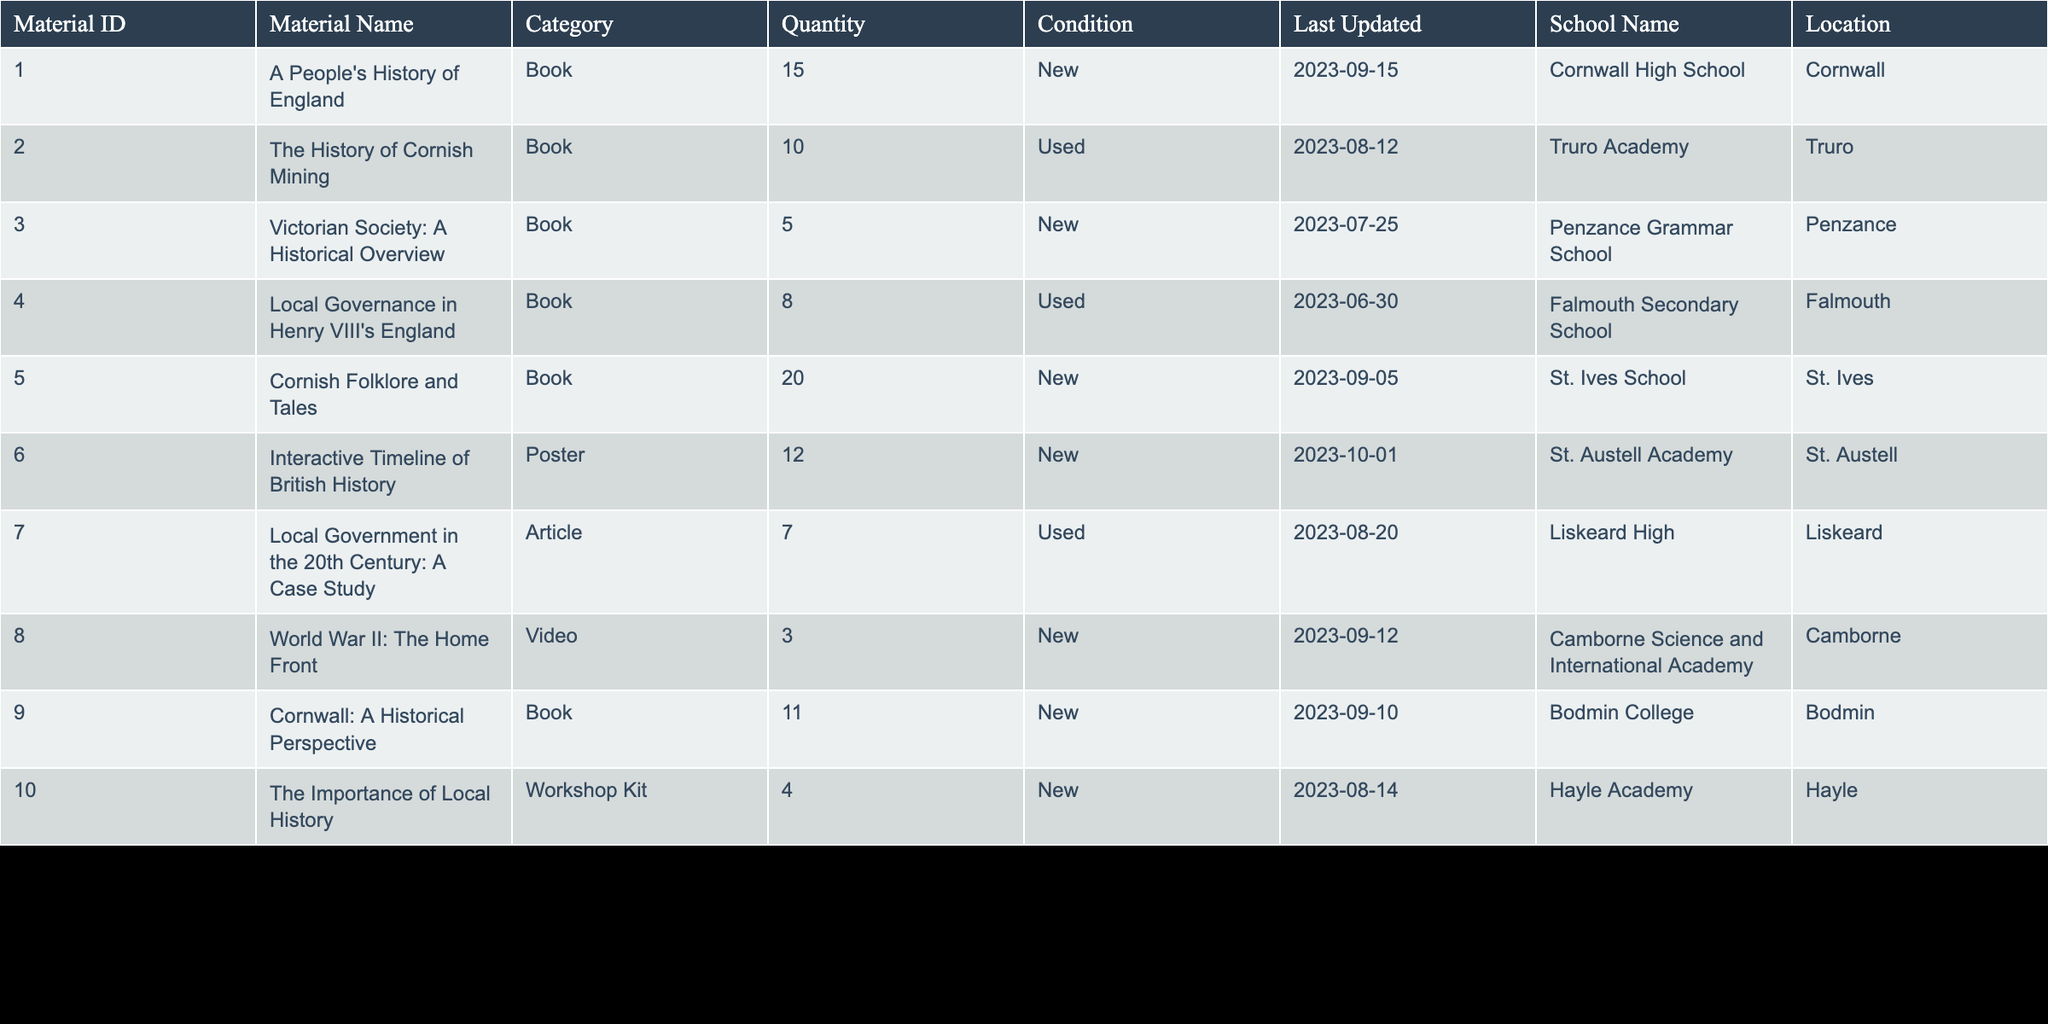What is the total quantity of books listed in the inventory? To find the total quantity of books, I will extract the quantities for all materials categorized as 'Book' from the table. The quantities for the books are 15, 10, 5, 8, 20, 11. Summing these gives 15 + 10 + 5 + 8 + 20 + 11 = 69.
Answer: 69 Which school has the highest quantity of educational materials? By reviewing the 'Quantity' column for all entries, I find that the highest quantity is 20, which belongs to 'Cornish Folklore and Tales' at 'St. Ives School'.
Answer: St. Ives School Are there any educational materials in used condition? Looking through the 'Condition' column, I see that there are materials with the condition marked as 'Used', specifically for 'The History of Cornish Mining', 'Local Governance in Henry VIII's England', and 'Local Government in the 20th Century: A Case Study'. Thus, the answer is yes.
Answer: Yes What is the average quantity of educational materials across all schools? First, I will sum the total quantities from the 'Quantity' column, which adds up to 73. There are 10 entries (materials), so the average is calculated as 73 / 10 = 7.3.
Answer: 7.3 Is there any educational material categorized as a 'Video'? The table lists 'World War II: The Home Front' under the 'Video' category, confirming the presence of video materials. Therefore, the answer is yes.
Answer: Yes How many educational materials have a quantity higher than 10? Reviewing the 'Quantity' column, the quantities greater than 10 are 15, 20, and 12. Counting those, I find there are 5 materials: 'A People's History of England', 'Cornish Folklore and Tales', and 'Interactive Timeline of British History'.
Answer: 5 What material was last updated most recently? Checking the 'Last Updated' column, 'Interactive Timeline of British History' has the most recent date of '2023-10-01'. Therefore, this material was last updated most recently.
Answer: Interactive Timeline of British History Which two schools have the least quantity of educational materials? I will compare the quantities listed for each school. The two schools with the least quantities are 'World War II: The Home Front' with 3 and 'Local Government in the 20th Century: A Case Study' with 7. Thus, the two schools are 'Camborne Science and International Academy' and 'Liskeard High'.
Answer: Camborne Science and International Academy, Liskeard High What is the total quantity of new condition materials? I will sum the quantities for all materials where the condition is 'New'. These quantities are 15, 5, 20, 12, 3, and 4. Adding these gives 15 + 5 + 20 + 12 + 3 + 4 = 59.
Answer: 59 